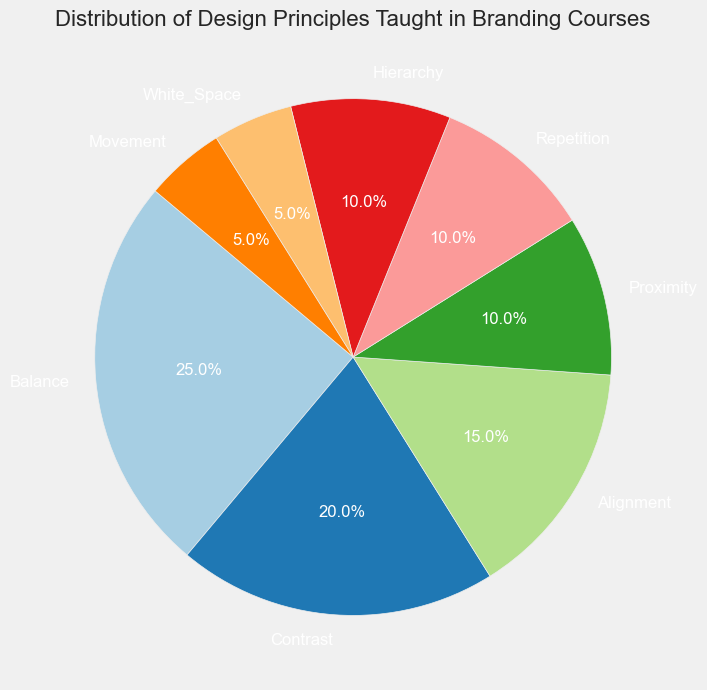What is the principle with the highest percentage? The figure shows that each segment of the pie represents a design principle, and "Balance" occupies the largest segment.
Answer: Balance Which two principles together make up 30% of the total? Reviewing the chart, "Alignment" accounts for 15% and "Proximity" accounts for 10%, together they sum to 25%. Adding "Movement" from the chart, which is 5%, reaches a total of 30%.
Answer: Alignment and Proximity Which principles each occupy 10% of the pie chart? The segments labeled "Proximity," "Repetition," and "Hierarchy" each cover 10% of the pie.
Answer: Proximity, Repetition, and Hierarchy What percentage of the total is made up by principles occupying less than 10%? "White_Space" and "Movement," each occupying 5%, together make up 10%.
Answer: 10% How does the proportion of "Balance" compare to "Alignment"? The "Balance" segment covers 25% of the pie, while "Alignment" covers only 15%. Hence, "Balance" has a higher percentage.
Answer: Balance is higher than Alignment What is the total percentage for principles related to layout (Balance, Alignment, Proximity)? Adding the percentages of "Balance" (25%), "Alignment" (15%), and "Proximity" (10%) gives 50%.
Answer: 50% Which principle has the smallest segment, and what is its percentage? By observing the chart, "White_Space" and "Movement" both occupy the smallest segments, each at 5%.
Answer: White_Space and Movement, 5% What is the difference in percentage between "Contrast" and "Hierarchy"? "Contrast" makes up 20% and "Hierarchy" makes up 10%. The difference is 20% - 10% = 10%.
Answer: 10% Is the combined percentage of the least covered principles (White_Space, Movement) more than the percentage of "Repetition"? Checking the chart, "White_Space" and "Movement" together account for 10% (5% each), which is equal to "Repetition's" 10%.
Answer: No 